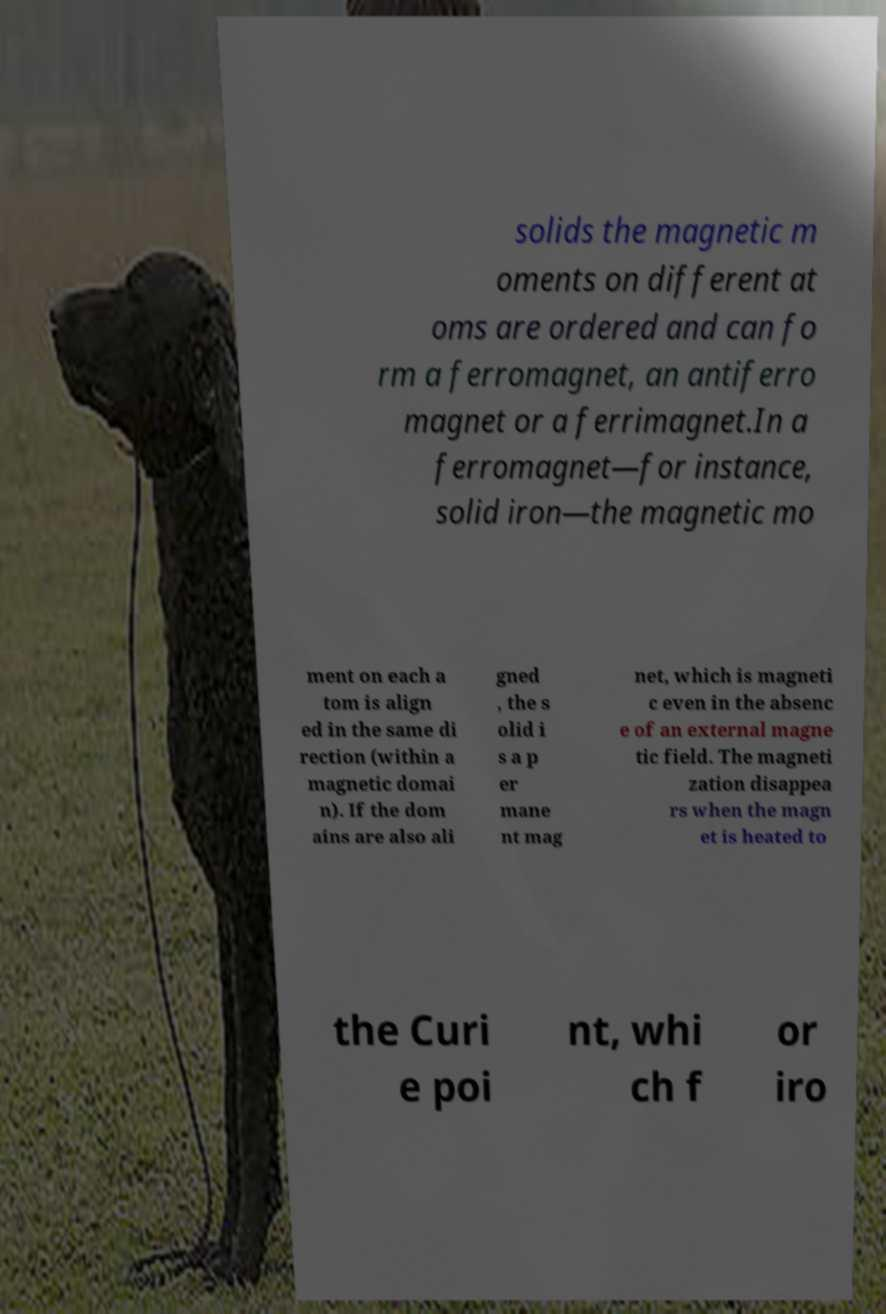I need the written content from this picture converted into text. Can you do that? solids the magnetic m oments on different at oms are ordered and can fo rm a ferromagnet, an antiferro magnet or a ferrimagnet.In a ferromagnet—for instance, solid iron—the magnetic mo ment on each a tom is align ed in the same di rection (within a magnetic domai n). If the dom ains are also ali gned , the s olid i s a p er mane nt mag net, which is magneti c even in the absenc e of an external magne tic field. The magneti zation disappea rs when the magn et is heated to the Curi e poi nt, whi ch f or iro 